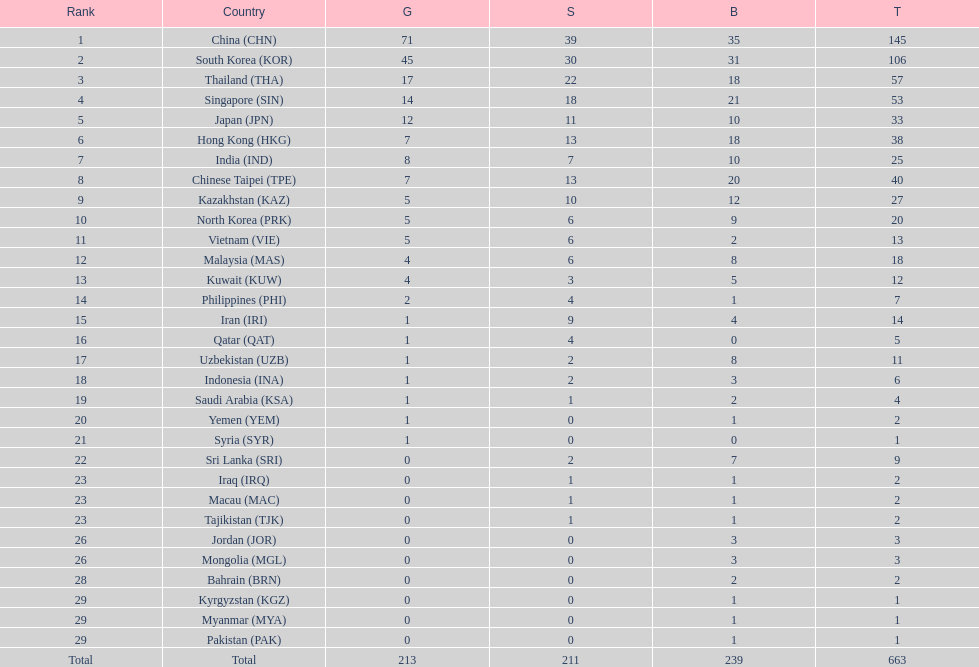How many nations earned at least ten bronze medals? 9. 